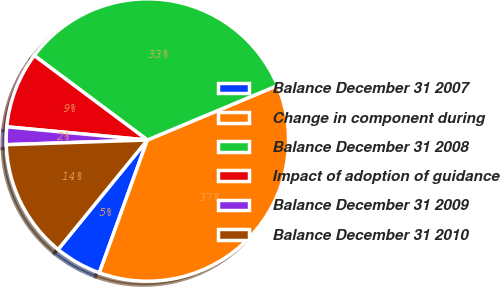<chart> <loc_0><loc_0><loc_500><loc_500><pie_chart><fcel>Balance December 31 2007<fcel>Change in component during<fcel>Balance December 31 2008<fcel>Impact of adoption of guidance<fcel>Balance December 31 2009<fcel>Balance December 31 2010<nl><fcel>5.37%<fcel>36.83%<fcel>33.48%<fcel>8.72%<fcel>2.02%<fcel>13.58%<nl></chart> 